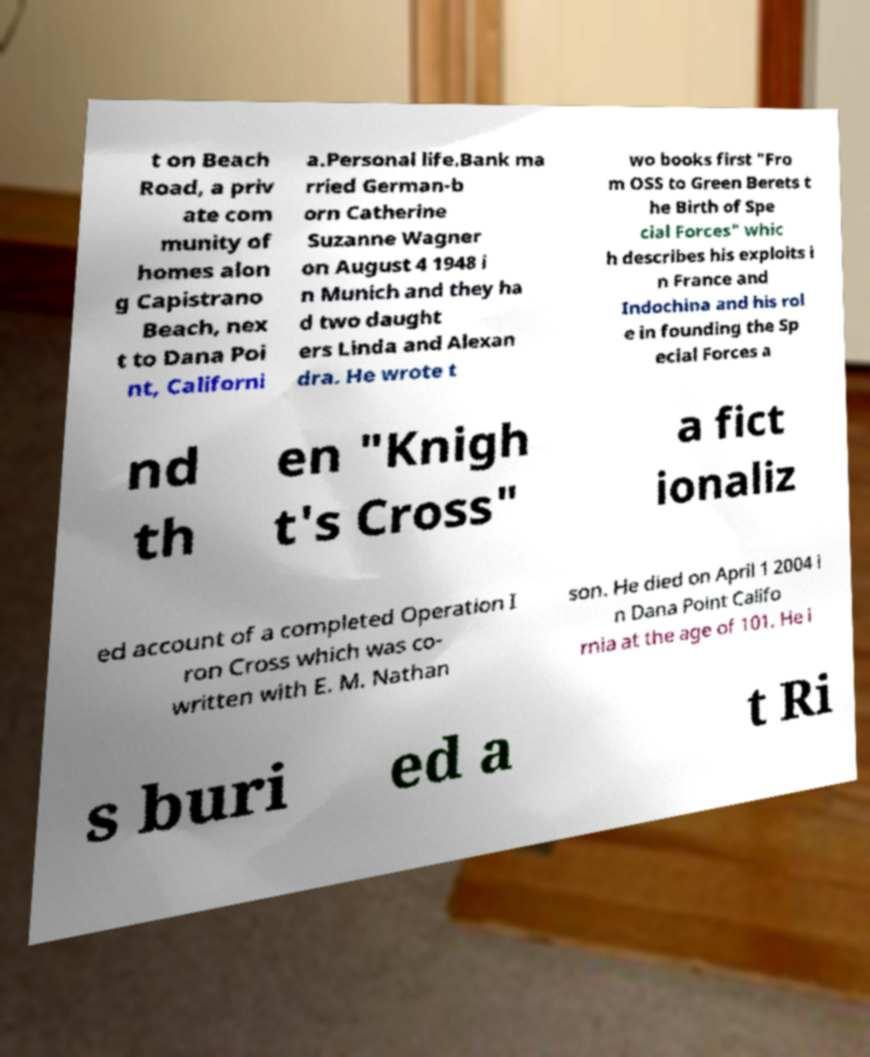Could you extract and type out the text from this image? t on Beach Road, a priv ate com munity of homes alon g Capistrano Beach, nex t to Dana Poi nt, Californi a.Personal life.Bank ma rried German-b orn Catherine Suzanne Wagner on August 4 1948 i n Munich and they ha d two daught ers Linda and Alexan dra. He wrote t wo books first "Fro m OSS to Green Berets t he Birth of Spe cial Forces" whic h describes his exploits i n France and Indochina and his rol e in founding the Sp ecial Forces a nd th en "Knigh t's Cross" a fict ionaliz ed account of a completed Operation I ron Cross which was co- written with E. M. Nathan son. He died on April 1 2004 i n Dana Point Califo rnia at the age of 101. He i s buri ed a t Ri 